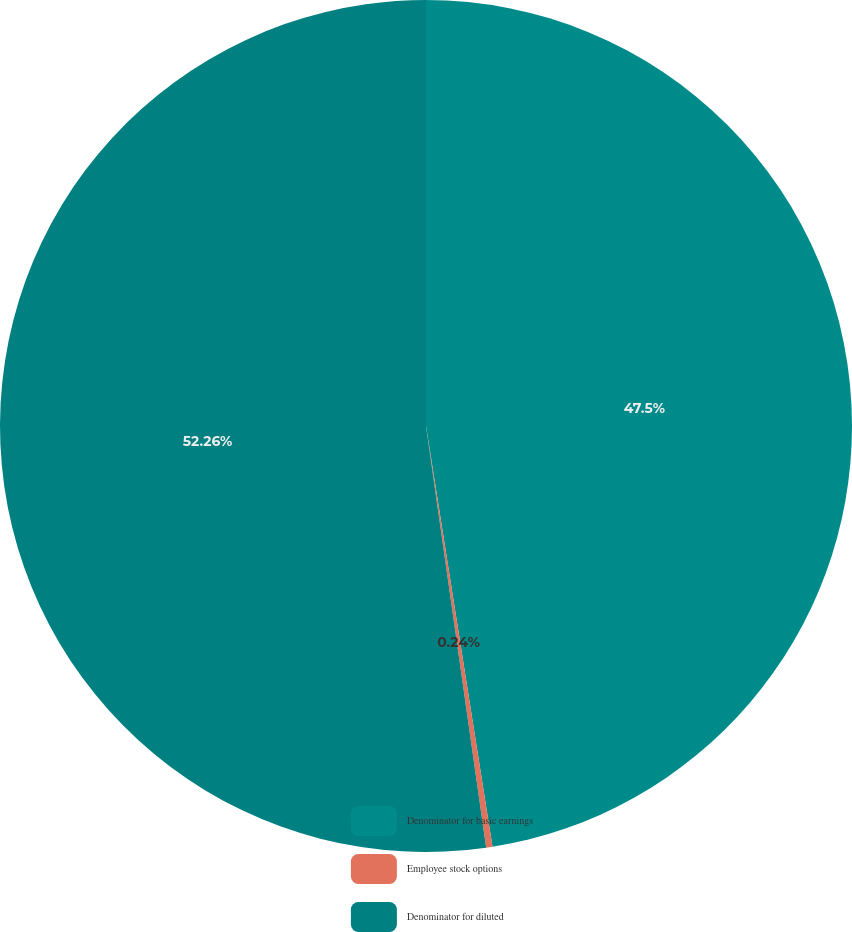Convert chart to OTSL. <chart><loc_0><loc_0><loc_500><loc_500><pie_chart><fcel>Denominator for basic earnings<fcel>Employee stock options<fcel>Denominator for diluted<nl><fcel>47.5%<fcel>0.24%<fcel>52.25%<nl></chart> 